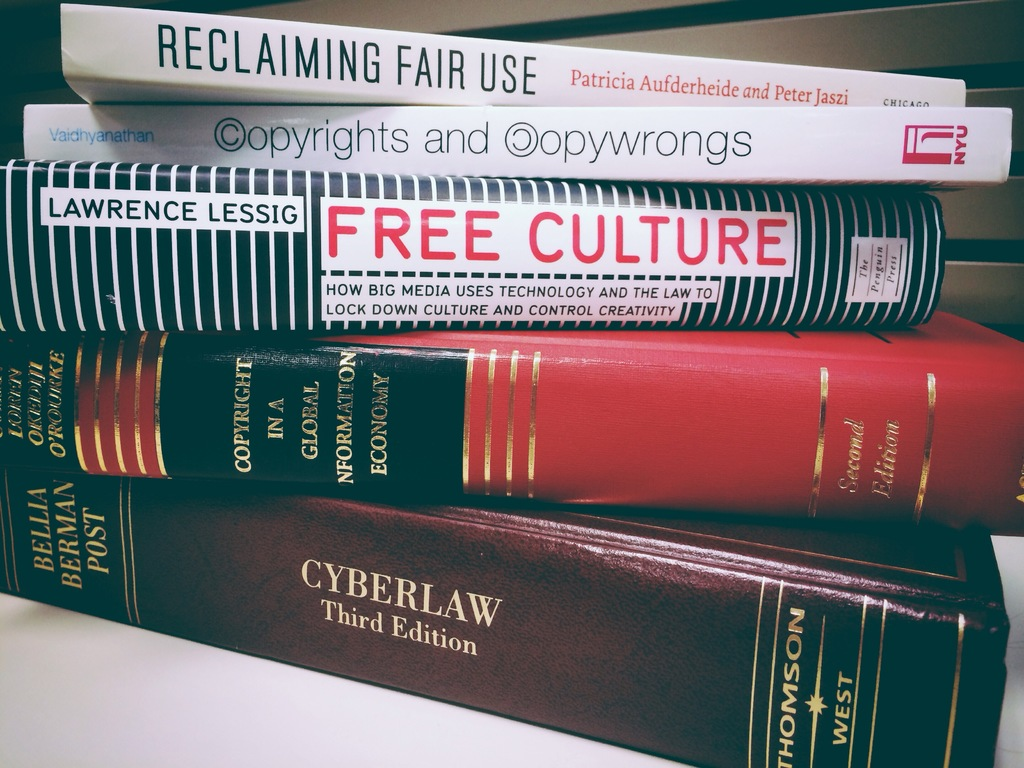Provide a one-sentence caption for the provided image. A stack of five critical texts on intellectual property and cyber law, featuring prominent works by authors like Lawrence Lessig and Patricia Aufderheide, highlight evolving discussions on media, technology, and copyright. 